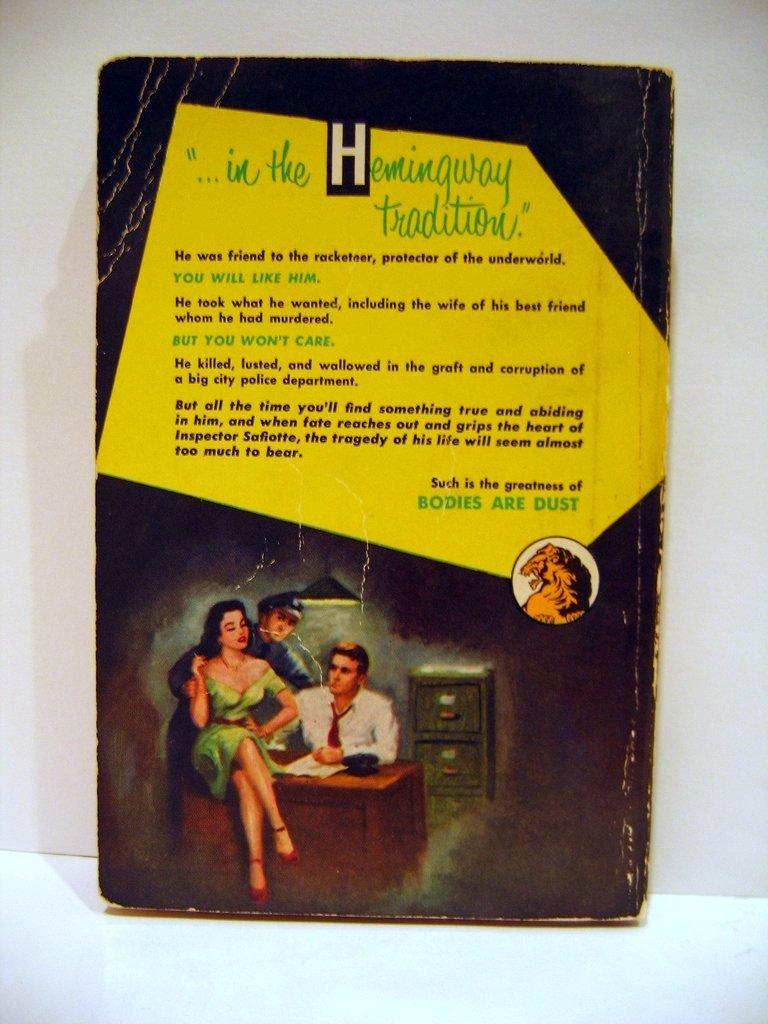<image>
Write a terse but informative summary of the picture. the back cover of a book reading "in the Hemingway tradition." 